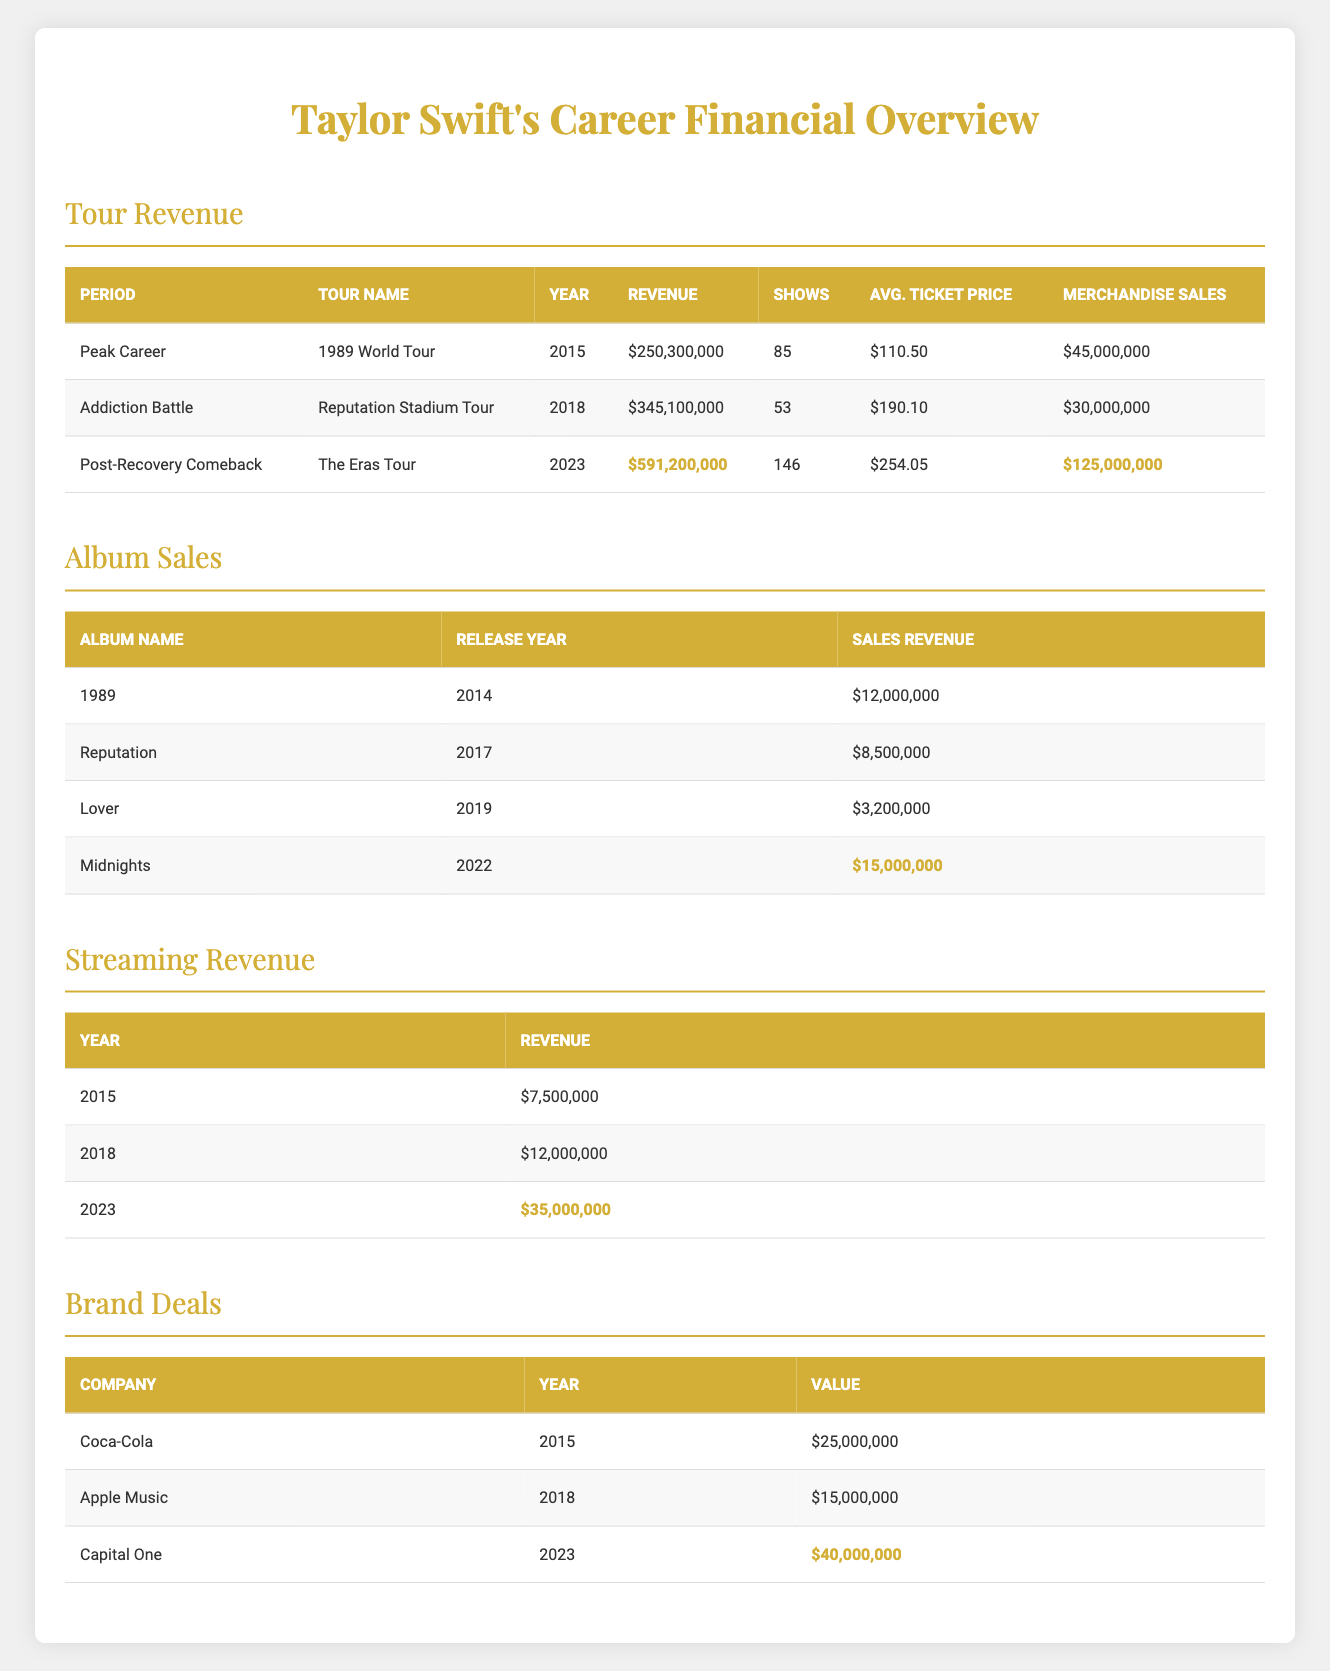What was the revenue from the 1989 World Tour? The revenue from the 1989 World Tour is listed in the table under the "Revenue" column for the "Peak Career" period. For the year 2015, this revenue is $250,300,000.
Answer: $250,300,000 Which tour had the highest average ticket price? To find the tour with the highest average ticket price, compare the "Avg. Ticket Price" values from each row. The prices are $110.50 for the 1989 World Tour, $190.10 for the Reputation Stadium Tour, and $254.05 for The Eras Tour. The highest is $254.05 from The Eras Tour.
Answer: $254.05 What is the total revenue generated from the album sales listed? Add up the sales revenue from each of the provided albums: $12,000,000 (1989) + $8,500,000 (Reputation) + $3,200,000 (Lover) + $15,000,000 (Midnights). The total is $12,000,000 + $8,500,000 + $3,200,000 + $15,000,000 = $38,700,000.
Answer: $38,700,000 Did the streaming revenue increase from 2015 to 2023? Compare the streaming revenue for 2015, which is $7,500,000, and for 2023, which is $35,000,000. Since $35,000,000 is greater than $7,500,000, the streaming revenue did increase.
Answer: Yes What was the year of the Reputation album's release, and how much did it earn? The Reputation album was released in 2017, and its sales revenue is listed as $8,500,000. This information is obtained from the "Album Sales" table.
Answer: 2017, $8,500,000 What is the difference in revenue between the Eras Tour and the Reputation Stadium Tour? Subtract the revenue of the Reputation Stadium Tour ($345,100,000) from the revenue of The Eras Tour ($591,200,000). The difference is $591,200,000 - $345,100,000 = $246,100,000.
Answer: $246,100,000 How much did merchandise sales generate during the Addiction Battle tour? Merchandise sales for the Reputation Stadium Tour (2018) are listed as $30,000,000 in the table under the "Merchandise Sales" column.
Answer: $30,000,000 Which brand deal generated the least revenue, and how much was it? Review the brand deals listed: Coca-Cola ($25,000,000), Apple Music ($15,000,000), and Capital One ($40,000,000). The least revenue is from Apple Music, totaling $15,000,000.
Answer: $15,000,000 What was the total revenue from the Post-Recovery Comeback, combining tour revenue, merchandise sales, and brand deals? The total is calculated by adding the Eras Tour revenue ($591,200,000), merchandise sales ($125,000,000), and Capital One brand deal ($40,000,000). The total revenue is $591,200,000 + $125,000,000 + $40,000,000 = $756,200,000.
Answer: $756,200,000 